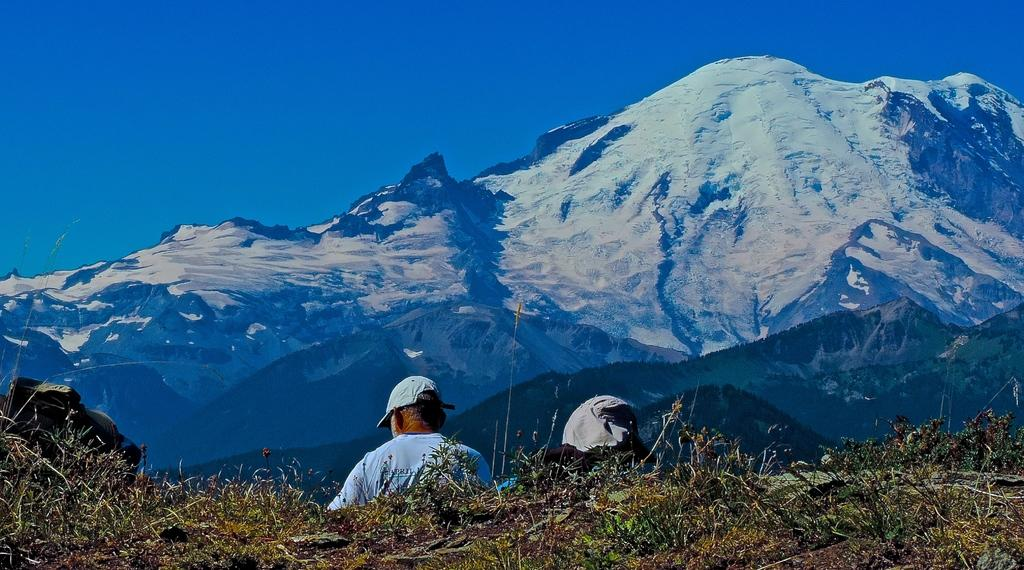What type of vegetation is at the bottom of the image? There is grass at the bottom of the image. How many people are in the image? There are two people in the image. What object can be seen in the image besides the people and grass? There is a bag in the image. What can be seen in the distance in the image? There are mountains in the background of the image. What is visible at the top of the image? The sky is visible at the top of the image. What type of advice does the manager give to the sister in the image? There is no manager or sister present in the image, and therefore no such interaction can be observed. How many icicles are hanging from the mountains in the image? There are no icicles visible in the image; only grass, two people, a bag, mountains, and the sky are present. 